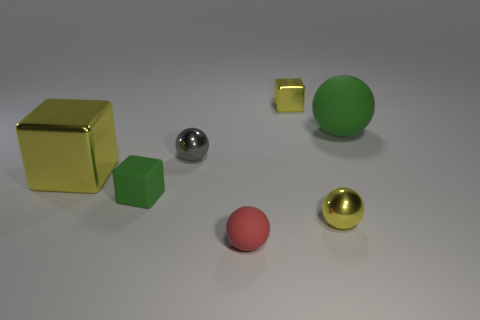There is a green cube that is the same size as the gray thing; what is its material?
Your answer should be compact. Rubber. Is there a small block that is to the left of the tiny yellow metal object that is behind the rubber sphere on the right side of the small rubber sphere?
Provide a short and direct response. Yes. Does the metal block behind the gray sphere have the same color as the metallic sphere on the right side of the tiny red matte ball?
Ensure brevity in your answer.  Yes. Is there a big blue block?
Give a very brief answer. No. What is the material of the large ball that is the same color as the matte block?
Keep it short and to the point. Rubber. What size is the metallic sphere that is in front of the small metal sphere that is behind the metallic ball that is in front of the tiny gray object?
Provide a succinct answer. Small. There is a big yellow metallic object; does it have the same shape as the green matte thing to the left of the green matte sphere?
Your answer should be very brief. Yes. Is there a small rubber sphere that has the same color as the large matte sphere?
Ensure brevity in your answer.  No. How many spheres are small matte objects or small red rubber objects?
Ensure brevity in your answer.  1. Are there any green rubber objects of the same shape as the red thing?
Give a very brief answer. Yes. 